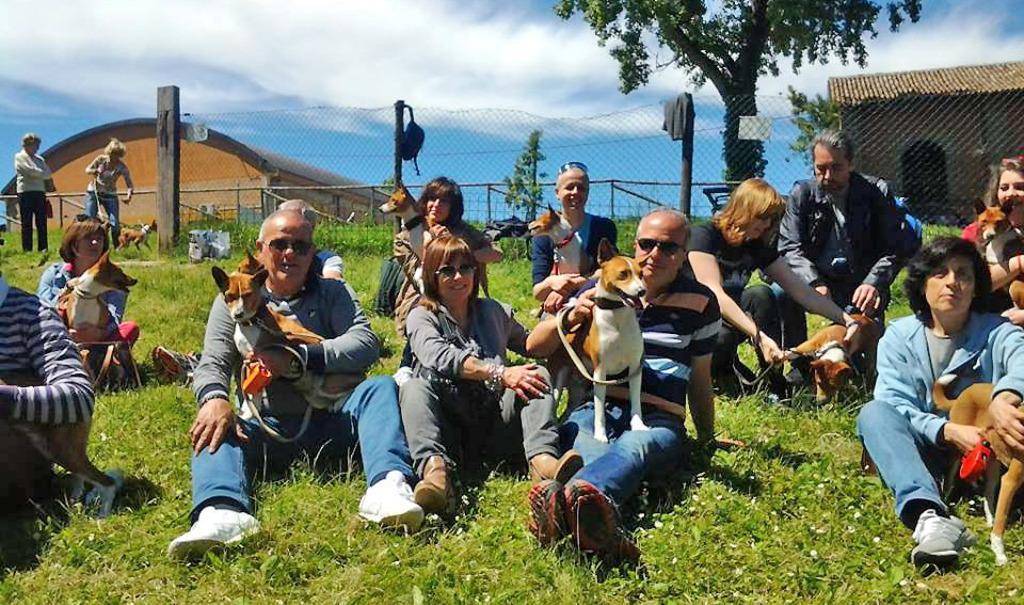Please provide a concise description of this image. In this image I can see there are persons sitting on the grass and holding a dog. And few persons are standing. And at the back there is a wooden pole and a shell attached to it. And there is a fence around it. And there are buildings and tree. And at the top there is a sky. 